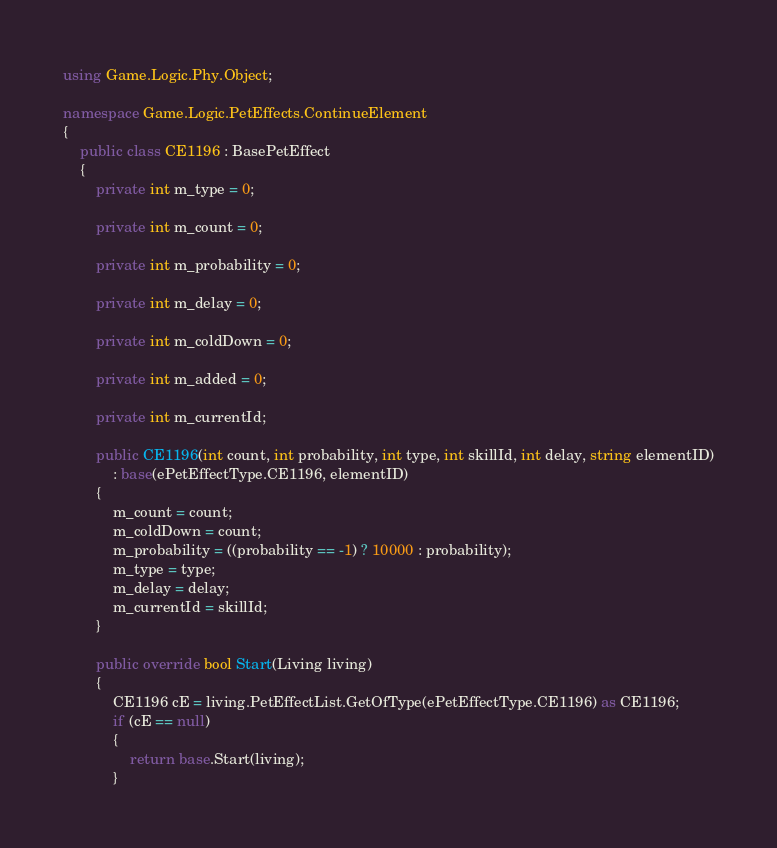<code> <loc_0><loc_0><loc_500><loc_500><_C#_>using Game.Logic.Phy.Object;

namespace Game.Logic.PetEffects.ContinueElement
{
	public class CE1196 : BasePetEffect
	{
		private int m_type = 0;

		private int m_count = 0;

		private int m_probability = 0;

		private int m_delay = 0;

		private int m_coldDown = 0;

		private int m_added = 0;

		private int m_currentId;

		public CE1196(int count, int probability, int type, int skillId, int delay, string elementID)
			: base(ePetEffectType.CE1196, elementID)
		{
			m_count = count;
			m_coldDown = count;
			m_probability = ((probability == -1) ? 10000 : probability);
			m_type = type;
			m_delay = delay;
			m_currentId = skillId;
		}

		public override bool Start(Living living)
		{
			CE1196 cE = living.PetEffectList.GetOfType(ePetEffectType.CE1196) as CE1196;
			if (cE == null)
			{
				return base.Start(living);
			}</code> 